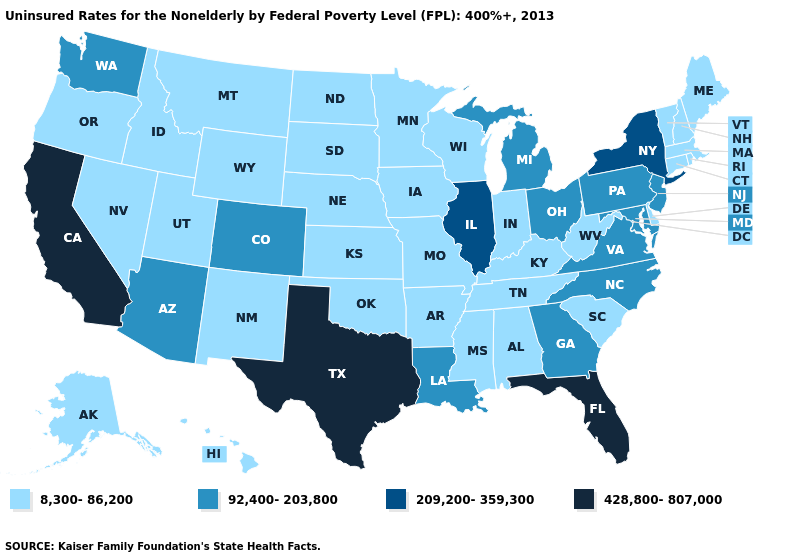What is the value of Nebraska?
Short answer required. 8,300-86,200. Name the states that have a value in the range 428,800-807,000?
Concise answer only. California, Florida, Texas. Does the first symbol in the legend represent the smallest category?
Write a very short answer. Yes. What is the value of Idaho?
Quick response, please. 8,300-86,200. How many symbols are there in the legend?
Be succinct. 4. Name the states that have a value in the range 92,400-203,800?
Keep it brief. Arizona, Colorado, Georgia, Louisiana, Maryland, Michigan, New Jersey, North Carolina, Ohio, Pennsylvania, Virginia, Washington. Which states hav the highest value in the MidWest?
Short answer required. Illinois. What is the highest value in the USA?
Quick response, please. 428,800-807,000. Does New Mexico have a lower value than Michigan?
Quick response, please. Yes. How many symbols are there in the legend?
Concise answer only. 4. Does Utah have the highest value in the USA?
Answer briefly. No. What is the lowest value in the Northeast?
Answer briefly. 8,300-86,200. Name the states that have a value in the range 209,200-359,300?
Concise answer only. Illinois, New York. Name the states that have a value in the range 209,200-359,300?
Be succinct. Illinois, New York. What is the highest value in states that border Iowa?
Be succinct. 209,200-359,300. 